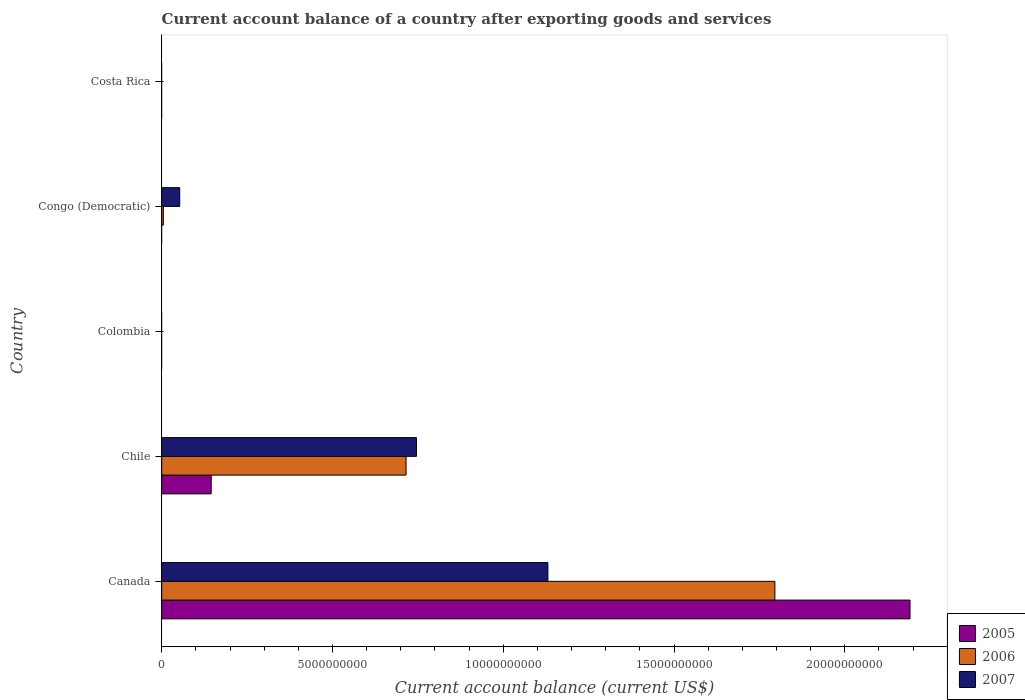Are the number of bars per tick equal to the number of legend labels?
Your response must be concise. No. What is the label of the 3rd group of bars from the top?
Ensure brevity in your answer.  Colombia. In how many cases, is the number of bars for a given country not equal to the number of legend labels?
Provide a short and direct response. 3. What is the account balance in 2007 in Chile?
Offer a very short reply. 7.46e+09. Across all countries, what is the maximum account balance in 2006?
Offer a terse response. 1.80e+1. What is the total account balance in 2005 in the graph?
Your answer should be very brief. 2.34e+1. What is the difference between the account balance in 2007 in Canada and that in Congo (Democratic)?
Give a very brief answer. 1.08e+1. What is the difference between the account balance in 2007 in Canada and the account balance in 2005 in Costa Rica?
Provide a succinct answer. 1.13e+1. What is the average account balance in 2005 per country?
Offer a very short reply. 4.67e+09. What is the difference between the account balance in 2007 and account balance in 2006 in Canada?
Make the answer very short. -6.65e+09. What is the ratio of the account balance in 2006 in Chile to that in Congo (Democratic)?
Give a very brief answer. 149.67. Is the difference between the account balance in 2007 in Canada and Congo (Democratic) greater than the difference between the account balance in 2006 in Canada and Congo (Democratic)?
Your response must be concise. No. What is the difference between the highest and the second highest account balance in 2007?
Your answer should be compact. 3.85e+09. What is the difference between the highest and the lowest account balance in 2007?
Offer a terse response. 1.13e+1. Is the sum of the account balance in 2006 in Canada and Congo (Democratic) greater than the maximum account balance in 2007 across all countries?
Offer a very short reply. Yes. How many countries are there in the graph?
Keep it short and to the point. 5. What is the difference between two consecutive major ticks on the X-axis?
Give a very brief answer. 5.00e+09. Does the graph contain grids?
Your answer should be compact. No. Where does the legend appear in the graph?
Keep it short and to the point. Bottom right. How many legend labels are there?
Ensure brevity in your answer.  3. What is the title of the graph?
Provide a short and direct response. Current account balance of a country after exporting goods and services. What is the label or title of the X-axis?
Your response must be concise. Current account balance (current US$). What is the Current account balance (current US$) in 2005 in Canada?
Offer a terse response. 2.19e+1. What is the Current account balance (current US$) of 2006 in Canada?
Your response must be concise. 1.80e+1. What is the Current account balance (current US$) in 2007 in Canada?
Offer a very short reply. 1.13e+1. What is the Current account balance (current US$) of 2005 in Chile?
Provide a succinct answer. 1.45e+09. What is the Current account balance (current US$) in 2006 in Chile?
Offer a very short reply. 7.15e+09. What is the Current account balance (current US$) of 2007 in Chile?
Make the answer very short. 7.46e+09. What is the Current account balance (current US$) of 2005 in Colombia?
Provide a succinct answer. 0. What is the Current account balance (current US$) in 2007 in Colombia?
Your response must be concise. 0. What is the Current account balance (current US$) of 2006 in Congo (Democratic)?
Keep it short and to the point. 4.78e+07. What is the Current account balance (current US$) in 2007 in Congo (Democratic)?
Give a very brief answer. 5.27e+08. What is the Current account balance (current US$) of 2007 in Costa Rica?
Offer a very short reply. 0. Across all countries, what is the maximum Current account balance (current US$) of 2005?
Your response must be concise. 2.19e+1. Across all countries, what is the maximum Current account balance (current US$) of 2006?
Ensure brevity in your answer.  1.80e+1. Across all countries, what is the maximum Current account balance (current US$) of 2007?
Give a very brief answer. 1.13e+1. Across all countries, what is the minimum Current account balance (current US$) in 2007?
Provide a short and direct response. 0. What is the total Current account balance (current US$) in 2005 in the graph?
Provide a succinct answer. 2.34e+1. What is the total Current account balance (current US$) of 2006 in the graph?
Offer a very short reply. 2.52e+1. What is the total Current account balance (current US$) in 2007 in the graph?
Provide a succinct answer. 1.93e+1. What is the difference between the Current account balance (current US$) in 2005 in Canada and that in Chile?
Offer a terse response. 2.05e+1. What is the difference between the Current account balance (current US$) in 2006 in Canada and that in Chile?
Ensure brevity in your answer.  1.08e+1. What is the difference between the Current account balance (current US$) of 2007 in Canada and that in Chile?
Your answer should be very brief. 3.85e+09. What is the difference between the Current account balance (current US$) in 2006 in Canada and that in Congo (Democratic)?
Keep it short and to the point. 1.79e+1. What is the difference between the Current account balance (current US$) in 2007 in Canada and that in Congo (Democratic)?
Your response must be concise. 1.08e+1. What is the difference between the Current account balance (current US$) of 2006 in Chile and that in Congo (Democratic)?
Ensure brevity in your answer.  7.11e+09. What is the difference between the Current account balance (current US$) in 2007 in Chile and that in Congo (Democratic)?
Give a very brief answer. 6.93e+09. What is the difference between the Current account balance (current US$) in 2005 in Canada and the Current account balance (current US$) in 2006 in Chile?
Provide a succinct answer. 1.48e+1. What is the difference between the Current account balance (current US$) in 2005 in Canada and the Current account balance (current US$) in 2007 in Chile?
Make the answer very short. 1.45e+1. What is the difference between the Current account balance (current US$) of 2006 in Canada and the Current account balance (current US$) of 2007 in Chile?
Offer a very short reply. 1.05e+1. What is the difference between the Current account balance (current US$) of 2005 in Canada and the Current account balance (current US$) of 2006 in Congo (Democratic)?
Give a very brief answer. 2.19e+1. What is the difference between the Current account balance (current US$) in 2005 in Canada and the Current account balance (current US$) in 2007 in Congo (Democratic)?
Provide a succinct answer. 2.14e+1. What is the difference between the Current account balance (current US$) of 2006 in Canada and the Current account balance (current US$) of 2007 in Congo (Democratic)?
Your answer should be compact. 1.74e+1. What is the difference between the Current account balance (current US$) of 2005 in Chile and the Current account balance (current US$) of 2006 in Congo (Democratic)?
Provide a succinct answer. 1.40e+09. What is the difference between the Current account balance (current US$) of 2005 in Chile and the Current account balance (current US$) of 2007 in Congo (Democratic)?
Ensure brevity in your answer.  9.22e+08. What is the difference between the Current account balance (current US$) of 2006 in Chile and the Current account balance (current US$) of 2007 in Congo (Democratic)?
Offer a very short reply. 6.63e+09. What is the average Current account balance (current US$) of 2005 per country?
Ensure brevity in your answer.  4.67e+09. What is the average Current account balance (current US$) of 2006 per country?
Offer a very short reply. 5.03e+09. What is the average Current account balance (current US$) of 2007 per country?
Ensure brevity in your answer.  3.86e+09. What is the difference between the Current account balance (current US$) of 2005 and Current account balance (current US$) of 2006 in Canada?
Ensure brevity in your answer.  3.96e+09. What is the difference between the Current account balance (current US$) in 2005 and Current account balance (current US$) in 2007 in Canada?
Offer a terse response. 1.06e+1. What is the difference between the Current account balance (current US$) in 2006 and Current account balance (current US$) in 2007 in Canada?
Your response must be concise. 6.65e+09. What is the difference between the Current account balance (current US$) of 2005 and Current account balance (current US$) of 2006 in Chile?
Provide a short and direct response. -5.71e+09. What is the difference between the Current account balance (current US$) in 2005 and Current account balance (current US$) in 2007 in Chile?
Offer a very short reply. -6.01e+09. What is the difference between the Current account balance (current US$) in 2006 and Current account balance (current US$) in 2007 in Chile?
Ensure brevity in your answer.  -3.04e+08. What is the difference between the Current account balance (current US$) of 2006 and Current account balance (current US$) of 2007 in Congo (Democratic)?
Make the answer very short. -4.79e+08. What is the ratio of the Current account balance (current US$) in 2005 in Canada to that in Chile?
Offer a very short reply. 15.12. What is the ratio of the Current account balance (current US$) of 2006 in Canada to that in Chile?
Ensure brevity in your answer.  2.51. What is the ratio of the Current account balance (current US$) of 2007 in Canada to that in Chile?
Your answer should be very brief. 1.52. What is the ratio of the Current account balance (current US$) in 2006 in Canada to that in Congo (Democratic)?
Your answer should be very brief. 375.6. What is the ratio of the Current account balance (current US$) in 2007 in Canada to that in Congo (Democratic)?
Keep it short and to the point. 21.46. What is the ratio of the Current account balance (current US$) of 2006 in Chile to that in Congo (Democratic)?
Offer a terse response. 149.67. What is the ratio of the Current account balance (current US$) of 2007 in Chile to that in Congo (Democratic)?
Give a very brief answer. 14.15. What is the difference between the highest and the second highest Current account balance (current US$) in 2006?
Your response must be concise. 1.08e+1. What is the difference between the highest and the second highest Current account balance (current US$) of 2007?
Your answer should be compact. 3.85e+09. What is the difference between the highest and the lowest Current account balance (current US$) in 2005?
Your answer should be compact. 2.19e+1. What is the difference between the highest and the lowest Current account balance (current US$) of 2006?
Provide a succinct answer. 1.80e+1. What is the difference between the highest and the lowest Current account balance (current US$) of 2007?
Ensure brevity in your answer.  1.13e+1. 